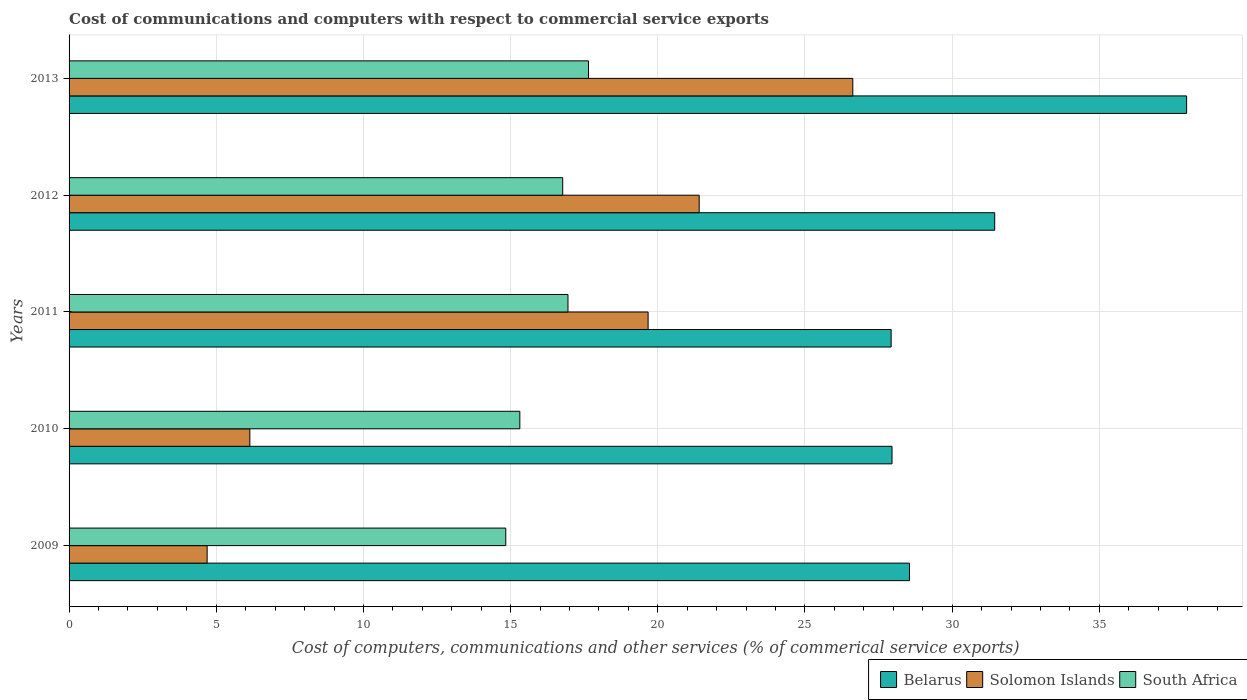How many groups of bars are there?
Provide a short and direct response. 5. How many bars are there on the 1st tick from the top?
Offer a terse response. 3. How many bars are there on the 5th tick from the bottom?
Offer a terse response. 3. What is the cost of communications and computers in Solomon Islands in 2009?
Give a very brief answer. 4.69. Across all years, what is the maximum cost of communications and computers in Belarus?
Provide a succinct answer. 37.97. Across all years, what is the minimum cost of communications and computers in Belarus?
Your answer should be compact. 27.93. In which year was the cost of communications and computers in South Africa minimum?
Give a very brief answer. 2009. What is the total cost of communications and computers in South Africa in the graph?
Offer a terse response. 81.51. What is the difference between the cost of communications and computers in Belarus in 2011 and that in 2012?
Your answer should be compact. -3.52. What is the difference between the cost of communications and computers in Solomon Islands in 2009 and the cost of communications and computers in Belarus in 2013?
Ensure brevity in your answer.  -33.27. What is the average cost of communications and computers in South Africa per year?
Make the answer very short. 16.3. In the year 2010, what is the difference between the cost of communications and computers in Belarus and cost of communications and computers in Solomon Islands?
Provide a short and direct response. 21.82. What is the ratio of the cost of communications and computers in Belarus in 2012 to that in 2013?
Give a very brief answer. 0.83. Is the cost of communications and computers in Solomon Islands in 2010 less than that in 2012?
Your answer should be compact. Yes. Is the difference between the cost of communications and computers in Belarus in 2010 and 2013 greater than the difference between the cost of communications and computers in Solomon Islands in 2010 and 2013?
Make the answer very short. Yes. What is the difference between the highest and the second highest cost of communications and computers in Solomon Islands?
Ensure brevity in your answer.  5.22. What is the difference between the highest and the lowest cost of communications and computers in Solomon Islands?
Make the answer very short. 21.93. Is the sum of the cost of communications and computers in South Africa in 2010 and 2012 greater than the maximum cost of communications and computers in Solomon Islands across all years?
Your answer should be very brief. Yes. What does the 3rd bar from the top in 2012 represents?
Your response must be concise. Belarus. What does the 1st bar from the bottom in 2011 represents?
Provide a short and direct response. Belarus. Is it the case that in every year, the sum of the cost of communications and computers in South Africa and cost of communications and computers in Solomon Islands is greater than the cost of communications and computers in Belarus?
Make the answer very short. No. Are all the bars in the graph horizontal?
Provide a short and direct response. Yes. What is the difference between two consecutive major ticks on the X-axis?
Provide a succinct answer. 5. Are the values on the major ticks of X-axis written in scientific E-notation?
Offer a very short reply. No. Does the graph contain any zero values?
Ensure brevity in your answer.  No. Does the graph contain grids?
Keep it short and to the point. Yes. How many legend labels are there?
Keep it short and to the point. 3. How are the legend labels stacked?
Your response must be concise. Horizontal. What is the title of the graph?
Keep it short and to the point. Cost of communications and computers with respect to commercial service exports. What is the label or title of the X-axis?
Provide a short and direct response. Cost of computers, communications and other services (% of commerical service exports). What is the Cost of computers, communications and other services (% of commerical service exports) in Belarus in 2009?
Keep it short and to the point. 28.55. What is the Cost of computers, communications and other services (% of commerical service exports) in Solomon Islands in 2009?
Offer a very short reply. 4.69. What is the Cost of computers, communications and other services (% of commerical service exports) in South Africa in 2009?
Provide a succinct answer. 14.84. What is the Cost of computers, communications and other services (% of commerical service exports) of Belarus in 2010?
Provide a short and direct response. 27.96. What is the Cost of computers, communications and other services (% of commerical service exports) of Solomon Islands in 2010?
Keep it short and to the point. 6.14. What is the Cost of computers, communications and other services (% of commerical service exports) of South Africa in 2010?
Keep it short and to the point. 15.31. What is the Cost of computers, communications and other services (% of commerical service exports) in Belarus in 2011?
Keep it short and to the point. 27.93. What is the Cost of computers, communications and other services (% of commerical service exports) of Solomon Islands in 2011?
Your answer should be very brief. 19.67. What is the Cost of computers, communications and other services (% of commerical service exports) in South Africa in 2011?
Provide a short and direct response. 16.95. What is the Cost of computers, communications and other services (% of commerical service exports) of Belarus in 2012?
Provide a short and direct response. 31.45. What is the Cost of computers, communications and other services (% of commerical service exports) of Solomon Islands in 2012?
Give a very brief answer. 21.41. What is the Cost of computers, communications and other services (% of commerical service exports) of South Africa in 2012?
Offer a terse response. 16.77. What is the Cost of computers, communications and other services (% of commerical service exports) of Belarus in 2013?
Keep it short and to the point. 37.97. What is the Cost of computers, communications and other services (% of commerical service exports) of Solomon Islands in 2013?
Make the answer very short. 26.63. What is the Cost of computers, communications and other services (% of commerical service exports) of South Africa in 2013?
Your answer should be very brief. 17.65. Across all years, what is the maximum Cost of computers, communications and other services (% of commerical service exports) in Belarus?
Offer a terse response. 37.97. Across all years, what is the maximum Cost of computers, communications and other services (% of commerical service exports) in Solomon Islands?
Ensure brevity in your answer.  26.63. Across all years, what is the maximum Cost of computers, communications and other services (% of commerical service exports) in South Africa?
Your answer should be compact. 17.65. Across all years, what is the minimum Cost of computers, communications and other services (% of commerical service exports) of Belarus?
Your answer should be very brief. 27.93. Across all years, what is the minimum Cost of computers, communications and other services (% of commerical service exports) in Solomon Islands?
Your response must be concise. 4.69. Across all years, what is the minimum Cost of computers, communications and other services (% of commerical service exports) in South Africa?
Give a very brief answer. 14.84. What is the total Cost of computers, communications and other services (% of commerical service exports) of Belarus in the graph?
Offer a terse response. 153.84. What is the total Cost of computers, communications and other services (% of commerical service exports) of Solomon Islands in the graph?
Your answer should be very brief. 78.53. What is the total Cost of computers, communications and other services (% of commerical service exports) of South Africa in the graph?
Your answer should be very brief. 81.51. What is the difference between the Cost of computers, communications and other services (% of commerical service exports) in Belarus in 2009 and that in 2010?
Your response must be concise. 0.59. What is the difference between the Cost of computers, communications and other services (% of commerical service exports) in Solomon Islands in 2009 and that in 2010?
Ensure brevity in your answer.  -1.45. What is the difference between the Cost of computers, communications and other services (% of commerical service exports) in South Africa in 2009 and that in 2010?
Offer a terse response. -0.48. What is the difference between the Cost of computers, communications and other services (% of commerical service exports) in Belarus in 2009 and that in 2011?
Offer a terse response. 0.62. What is the difference between the Cost of computers, communications and other services (% of commerical service exports) in Solomon Islands in 2009 and that in 2011?
Give a very brief answer. -14.98. What is the difference between the Cost of computers, communications and other services (% of commerical service exports) of South Africa in 2009 and that in 2011?
Make the answer very short. -2.11. What is the difference between the Cost of computers, communications and other services (% of commerical service exports) in Belarus in 2009 and that in 2012?
Your answer should be very brief. -2.9. What is the difference between the Cost of computers, communications and other services (% of commerical service exports) in Solomon Islands in 2009 and that in 2012?
Ensure brevity in your answer.  -16.72. What is the difference between the Cost of computers, communications and other services (% of commerical service exports) in South Africa in 2009 and that in 2012?
Keep it short and to the point. -1.93. What is the difference between the Cost of computers, communications and other services (% of commerical service exports) in Belarus in 2009 and that in 2013?
Your answer should be compact. -9.42. What is the difference between the Cost of computers, communications and other services (% of commerical service exports) in Solomon Islands in 2009 and that in 2013?
Your answer should be very brief. -21.93. What is the difference between the Cost of computers, communications and other services (% of commerical service exports) of South Africa in 2009 and that in 2013?
Give a very brief answer. -2.81. What is the difference between the Cost of computers, communications and other services (% of commerical service exports) of Belarus in 2010 and that in 2011?
Provide a succinct answer. 0.03. What is the difference between the Cost of computers, communications and other services (% of commerical service exports) in Solomon Islands in 2010 and that in 2011?
Offer a terse response. -13.53. What is the difference between the Cost of computers, communications and other services (% of commerical service exports) in South Africa in 2010 and that in 2011?
Your answer should be compact. -1.64. What is the difference between the Cost of computers, communications and other services (% of commerical service exports) of Belarus in 2010 and that in 2012?
Your answer should be compact. -3.49. What is the difference between the Cost of computers, communications and other services (% of commerical service exports) in Solomon Islands in 2010 and that in 2012?
Make the answer very short. -15.26. What is the difference between the Cost of computers, communications and other services (% of commerical service exports) of South Africa in 2010 and that in 2012?
Your answer should be compact. -1.46. What is the difference between the Cost of computers, communications and other services (% of commerical service exports) in Belarus in 2010 and that in 2013?
Your answer should be very brief. -10.01. What is the difference between the Cost of computers, communications and other services (% of commerical service exports) of Solomon Islands in 2010 and that in 2013?
Offer a terse response. -20.48. What is the difference between the Cost of computers, communications and other services (% of commerical service exports) in South Africa in 2010 and that in 2013?
Give a very brief answer. -2.33. What is the difference between the Cost of computers, communications and other services (% of commerical service exports) in Belarus in 2011 and that in 2012?
Give a very brief answer. -3.52. What is the difference between the Cost of computers, communications and other services (% of commerical service exports) of Solomon Islands in 2011 and that in 2012?
Give a very brief answer. -1.74. What is the difference between the Cost of computers, communications and other services (% of commerical service exports) in South Africa in 2011 and that in 2012?
Keep it short and to the point. 0.18. What is the difference between the Cost of computers, communications and other services (% of commerical service exports) in Belarus in 2011 and that in 2013?
Offer a terse response. -10.04. What is the difference between the Cost of computers, communications and other services (% of commerical service exports) of Solomon Islands in 2011 and that in 2013?
Keep it short and to the point. -6.95. What is the difference between the Cost of computers, communications and other services (% of commerical service exports) of South Africa in 2011 and that in 2013?
Keep it short and to the point. -0.7. What is the difference between the Cost of computers, communications and other services (% of commerical service exports) of Belarus in 2012 and that in 2013?
Make the answer very short. -6.52. What is the difference between the Cost of computers, communications and other services (% of commerical service exports) in Solomon Islands in 2012 and that in 2013?
Offer a terse response. -5.22. What is the difference between the Cost of computers, communications and other services (% of commerical service exports) of South Africa in 2012 and that in 2013?
Your answer should be very brief. -0.88. What is the difference between the Cost of computers, communications and other services (% of commerical service exports) of Belarus in 2009 and the Cost of computers, communications and other services (% of commerical service exports) of Solomon Islands in 2010?
Offer a very short reply. 22.41. What is the difference between the Cost of computers, communications and other services (% of commerical service exports) in Belarus in 2009 and the Cost of computers, communications and other services (% of commerical service exports) in South Africa in 2010?
Give a very brief answer. 13.24. What is the difference between the Cost of computers, communications and other services (% of commerical service exports) of Solomon Islands in 2009 and the Cost of computers, communications and other services (% of commerical service exports) of South Africa in 2010?
Offer a very short reply. -10.62. What is the difference between the Cost of computers, communications and other services (% of commerical service exports) in Belarus in 2009 and the Cost of computers, communications and other services (% of commerical service exports) in Solomon Islands in 2011?
Ensure brevity in your answer.  8.88. What is the difference between the Cost of computers, communications and other services (% of commerical service exports) in Belarus in 2009 and the Cost of computers, communications and other services (% of commerical service exports) in South Africa in 2011?
Offer a terse response. 11.6. What is the difference between the Cost of computers, communications and other services (% of commerical service exports) of Solomon Islands in 2009 and the Cost of computers, communications and other services (% of commerical service exports) of South Africa in 2011?
Offer a terse response. -12.26. What is the difference between the Cost of computers, communications and other services (% of commerical service exports) in Belarus in 2009 and the Cost of computers, communications and other services (% of commerical service exports) in Solomon Islands in 2012?
Your answer should be very brief. 7.14. What is the difference between the Cost of computers, communications and other services (% of commerical service exports) in Belarus in 2009 and the Cost of computers, communications and other services (% of commerical service exports) in South Africa in 2012?
Provide a short and direct response. 11.78. What is the difference between the Cost of computers, communications and other services (% of commerical service exports) in Solomon Islands in 2009 and the Cost of computers, communications and other services (% of commerical service exports) in South Africa in 2012?
Ensure brevity in your answer.  -12.08. What is the difference between the Cost of computers, communications and other services (% of commerical service exports) of Belarus in 2009 and the Cost of computers, communications and other services (% of commerical service exports) of Solomon Islands in 2013?
Provide a short and direct response. 1.92. What is the difference between the Cost of computers, communications and other services (% of commerical service exports) of Belarus in 2009 and the Cost of computers, communications and other services (% of commerical service exports) of South Africa in 2013?
Make the answer very short. 10.9. What is the difference between the Cost of computers, communications and other services (% of commerical service exports) in Solomon Islands in 2009 and the Cost of computers, communications and other services (% of commerical service exports) in South Africa in 2013?
Ensure brevity in your answer.  -12.95. What is the difference between the Cost of computers, communications and other services (% of commerical service exports) of Belarus in 2010 and the Cost of computers, communications and other services (% of commerical service exports) of Solomon Islands in 2011?
Provide a succinct answer. 8.29. What is the difference between the Cost of computers, communications and other services (% of commerical service exports) of Belarus in 2010 and the Cost of computers, communications and other services (% of commerical service exports) of South Africa in 2011?
Offer a terse response. 11.01. What is the difference between the Cost of computers, communications and other services (% of commerical service exports) of Solomon Islands in 2010 and the Cost of computers, communications and other services (% of commerical service exports) of South Africa in 2011?
Offer a very short reply. -10.81. What is the difference between the Cost of computers, communications and other services (% of commerical service exports) of Belarus in 2010 and the Cost of computers, communications and other services (% of commerical service exports) of Solomon Islands in 2012?
Your answer should be very brief. 6.55. What is the difference between the Cost of computers, communications and other services (% of commerical service exports) of Belarus in 2010 and the Cost of computers, communications and other services (% of commerical service exports) of South Africa in 2012?
Your answer should be compact. 11.19. What is the difference between the Cost of computers, communications and other services (% of commerical service exports) of Solomon Islands in 2010 and the Cost of computers, communications and other services (% of commerical service exports) of South Africa in 2012?
Your answer should be very brief. -10.63. What is the difference between the Cost of computers, communications and other services (% of commerical service exports) in Belarus in 2010 and the Cost of computers, communications and other services (% of commerical service exports) in Solomon Islands in 2013?
Keep it short and to the point. 1.33. What is the difference between the Cost of computers, communications and other services (% of commerical service exports) of Belarus in 2010 and the Cost of computers, communications and other services (% of commerical service exports) of South Africa in 2013?
Make the answer very short. 10.31. What is the difference between the Cost of computers, communications and other services (% of commerical service exports) of Solomon Islands in 2010 and the Cost of computers, communications and other services (% of commerical service exports) of South Africa in 2013?
Offer a very short reply. -11.5. What is the difference between the Cost of computers, communications and other services (% of commerical service exports) of Belarus in 2011 and the Cost of computers, communications and other services (% of commerical service exports) of Solomon Islands in 2012?
Offer a terse response. 6.52. What is the difference between the Cost of computers, communications and other services (% of commerical service exports) in Belarus in 2011 and the Cost of computers, communications and other services (% of commerical service exports) in South Africa in 2012?
Provide a succinct answer. 11.16. What is the difference between the Cost of computers, communications and other services (% of commerical service exports) in Solomon Islands in 2011 and the Cost of computers, communications and other services (% of commerical service exports) in South Africa in 2012?
Make the answer very short. 2.9. What is the difference between the Cost of computers, communications and other services (% of commerical service exports) in Belarus in 2011 and the Cost of computers, communications and other services (% of commerical service exports) in Solomon Islands in 2013?
Your response must be concise. 1.3. What is the difference between the Cost of computers, communications and other services (% of commerical service exports) of Belarus in 2011 and the Cost of computers, communications and other services (% of commerical service exports) of South Africa in 2013?
Keep it short and to the point. 10.28. What is the difference between the Cost of computers, communications and other services (% of commerical service exports) in Solomon Islands in 2011 and the Cost of computers, communications and other services (% of commerical service exports) in South Africa in 2013?
Your answer should be compact. 2.03. What is the difference between the Cost of computers, communications and other services (% of commerical service exports) in Belarus in 2012 and the Cost of computers, communications and other services (% of commerical service exports) in Solomon Islands in 2013?
Give a very brief answer. 4.82. What is the difference between the Cost of computers, communications and other services (% of commerical service exports) in Belarus in 2012 and the Cost of computers, communications and other services (% of commerical service exports) in South Africa in 2013?
Give a very brief answer. 13.8. What is the difference between the Cost of computers, communications and other services (% of commerical service exports) in Solomon Islands in 2012 and the Cost of computers, communications and other services (% of commerical service exports) in South Africa in 2013?
Your response must be concise. 3.76. What is the average Cost of computers, communications and other services (% of commerical service exports) in Belarus per year?
Ensure brevity in your answer.  30.77. What is the average Cost of computers, communications and other services (% of commerical service exports) of Solomon Islands per year?
Offer a terse response. 15.71. What is the average Cost of computers, communications and other services (% of commerical service exports) in South Africa per year?
Ensure brevity in your answer.  16.3. In the year 2009, what is the difference between the Cost of computers, communications and other services (% of commerical service exports) in Belarus and Cost of computers, communications and other services (% of commerical service exports) in Solomon Islands?
Make the answer very short. 23.86. In the year 2009, what is the difference between the Cost of computers, communications and other services (% of commerical service exports) of Belarus and Cost of computers, communications and other services (% of commerical service exports) of South Africa?
Offer a terse response. 13.71. In the year 2009, what is the difference between the Cost of computers, communications and other services (% of commerical service exports) in Solomon Islands and Cost of computers, communications and other services (% of commerical service exports) in South Africa?
Your response must be concise. -10.14. In the year 2010, what is the difference between the Cost of computers, communications and other services (% of commerical service exports) in Belarus and Cost of computers, communications and other services (% of commerical service exports) in Solomon Islands?
Ensure brevity in your answer.  21.82. In the year 2010, what is the difference between the Cost of computers, communications and other services (% of commerical service exports) of Belarus and Cost of computers, communications and other services (% of commerical service exports) of South Africa?
Ensure brevity in your answer.  12.64. In the year 2010, what is the difference between the Cost of computers, communications and other services (% of commerical service exports) of Solomon Islands and Cost of computers, communications and other services (% of commerical service exports) of South Africa?
Your response must be concise. -9.17. In the year 2011, what is the difference between the Cost of computers, communications and other services (% of commerical service exports) in Belarus and Cost of computers, communications and other services (% of commerical service exports) in Solomon Islands?
Keep it short and to the point. 8.26. In the year 2011, what is the difference between the Cost of computers, communications and other services (% of commerical service exports) in Belarus and Cost of computers, communications and other services (% of commerical service exports) in South Africa?
Offer a very short reply. 10.98. In the year 2011, what is the difference between the Cost of computers, communications and other services (% of commerical service exports) of Solomon Islands and Cost of computers, communications and other services (% of commerical service exports) of South Africa?
Make the answer very short. 2.72. In the year 2012, what is the difference between the Cost of computers, communications and other services (% of commerical service exports) in Belarus and Cost of computers, communications and other services (% of commerical service exports) in Solomon Islands?
Give a very brief answer. 10.04. In the year 2012, what is the difference between the Cost of computers, communications and other services (% of commerical service exports) in Belarus and Cost of computers, communications and other services (% of commerical service exports) in South Africa?
Provide a short and direct response. 14.68. In the year 2012, what is the difference between the Cost of computers, communications and other services (% of commerical service exports) in Solomon Islands and Cost of computers, communications and other services (% of commerical service exports) in South Africa?
Make the answer very short. 4.64. In the year 2013, what is the difference between the Cost of computers, communications and other services (% of commerical service exports) in Belarus and Cost of computers, communications and other services (% of commerical service exports) in Solomon Islands?
Give a very brief answer. 11.34. In the year 2013, what is the difference between the Cost of computers, communications and other services (% of commerical service exports) of Belarus and Cost of computers, communications and other services (% of commerical service exports) of South Africa?
Offer a very short reply. 20.32. In the year 2013, what is the difference between the Cost of computers, communications and other services (% of commerical service exports) in Solomon Islands and Cost of computers, communications and other services (% of commerical service exports) in South Africa?
Provide a short and direct response. 8.98. What is the ratio of the Cost of computers, communications and other services (% of commerical service exports) in Belarus in 2009 to that in 2010?
Your response must be concise. 1.02. What is the ratio of the Cost of computers, communications and other services (% of commerical service exports) of Solomon Islands in 2009 to that in 2010?
Keep it short and to the point. 0.76. What is the ratio of the Cost of computers, communications and other services (% of commerical service exports) of South Africa in 2009 to that in 2010?
Your response must be concise. 0.97. What is the ratio of the Cost of computers, communications and other services (% of commerical service exports) of Belarus in 2009 to that in 2011?
Offer a terse response. 1.02. What is the ratio of the Cost of computers, communications and other services (% of commerical service exports) of Solomon Islands in 2009 to that in 2011?
Ensure brevity in your answer.  0.24. What is the ratio of the Cost of computers, communications and other services (% of commerical service exports) in South Africa in 2009 to that in 2011?
Make the answer very short. 0.88. What is the ratio of the Cost of computers, communications and other services (% of commerical service exports) of Belarus in 2009 to that in 2012?
Your answer should be compact. 0.91. What is the ratio of the Cost of computers, communications and other services (% of commerical service exports) in Solomon Islands in 2009 to that in 2012?
Provide a short and direct response. 0.22. What is the ratio of the Cost of computers, communications and other services (% of commerical service exports) in South Africa in 2009 to that in 2012?
Your answer should be very brief. 0.88. What is the ratio of the Cost of computers, communications and other services (% of commerical service exports) in Belarus in 2009 to that in 2013?
Your answer should be compact. 0.75. What is the ratio of the Cost of computers, communications and other services (% of commerical service exports) in Solomon Islands in 2009 to that in 2013?
Provide a short and direct response. 0.18. What is the ratio of the Cost of computers, communications and other services (% of commerical service exports) of South Africa in 2009 to that in 2013?
Offer a very short reply. 0.84. What is the ratio of the Cost of computers, communications and other services (% of commerical service exports) of Solomon Islands in 2010 to that in 2011?
Your answer should be very brief. 0.31. What is the ratio of the Cost of computers, communications and other services (% of commerical service exports) of South Africa in 2010 to that in 2011?
Your answer should be compact. 0.9. What is the ratio of the Cost of computers, communications and other services (% of commerical service exports) in Belarus in 2010 to that in 2012?
Your answer should be compact. 0.89. What is the ratio of the Cost of computers, communications and other services (% of commerical service exports) in Solomon Islands in 2010 to that in 2012?
Your answer should be compact. 0.29. What is the ratio of the Cost of computers, communications and other services (% of commerical service exports) in South Africa in 2010 to that in 2012?
Make the answer very short. 0.91. What is the ratio of the Cost of computers, communications and other services (% of commerical service exports) in Belarus in 2010 to that in 2013?
Your answer should be very brief. 0.74. What is the ratio of the Cost of computers, communications and other services (% of commerical service exports) in Solomon Islands in 2010 to that in 2013?
Your answer should be very brief. 0.23. What is the ratio of the Cost of computers, communications and other services (% of commerical service exports) in South Africa in 2010 to that in 2013?
Provide a succinct answer. 0.87. What is the ratio of the Cost of computers, communications and other services (% of commerical service exports) of Belarus in 2011 to that in 2012?
Make the answer very short. 0.89. What is the ratio of the Cost of computers, communications and other services (% of commerical service exports) of Solomon Islands in 2011 to that in 2012?
Your answer should be compact. 0.92. What is the ratio of the Cost of computers, communications and other services (% of commerical service exports) of South Africa in 2011 to that in 2012?
Keep it short and to the point. 1.01. What is the ratio of the Cost of computers, communications and other services (% of commerical service exports) of Belarus in 2011 to that in 2013?
Provide a succinct answer. 0.74. What is the ratio of the Cost of computers, communications and other services (% of commerical service exports) of Solomon Islands in 2011 to that in 2013?
Your answer should be very brief. 0.74. What is the ratio of the Cost of computers, communications and other services (% of commerical service exports) in South Africa in 2011 to that in 2013?
Offer a terse response. 0.96. What is the ratio of the Cost of computers, communications and other services (% of commerical service exports) in Belarus in 2012 to that in 2013?
Provide a short and direct response. 0.83. What is the ratio of the Cost of computers, communications and other services (% of commerical service exports) of Solomon Islands in 2012 to that in 2013?
Keep it short and to the point. 0.8. What is the ratio of the Cost of computers, communications and other services (% of commerical service exports) in South Africa in 2012 to that in 2013?
Offer a very short reply. 0.95. What is the difference between the highest and the second highest Cost of computers, communications and other services (% of commerical service exports) in Belarus?
Give a very brief answer. 6.52. What is the difference between the highest and the second highest Cost of computers, communications and other services (% of commerical service exports) of Solomon Islands?
Offer a very short reply. 5.22. What is the difference between the highest and the second highest Cost of computers, communications and other services (% of commerical service exports) in South Africa?
Provide a short and direct response. 0.7. What is the difference between the highest and the lowest Cost of computers, communications and other services (% of commerical service exports) in Belarus?
Ensure brevity in your answer.  10.04. What is the difference between the highest and the lowest Cost of computers, communications and other services (% of commerical service exports) of Solomon Islands?
Give a very brief answer. 21.93. What is the difference between the highest and the lowest Cost of computers, communications and other services (% of commerical service exports) in South Africa?
Your answer should be compact. 2.81. 